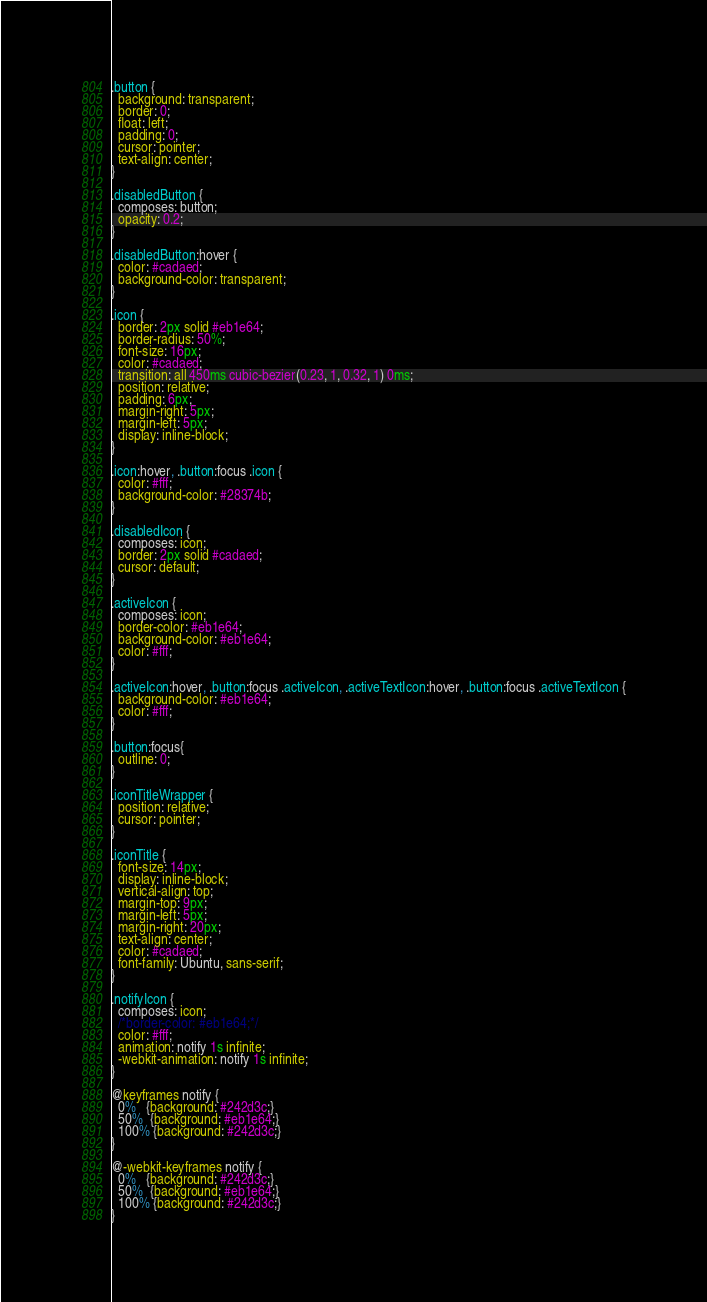Convert code to text. <code><loc_0><loc_0><loc_500><loc_500><_CSS_>.button {
  background: transparent;
  border: 0;
  float: left;
  padding: 0;
  cursor: pointer;
  text-align: center;
}

.disabledButton {
  composes: button;
  opacity: 0.2;
}

.disabledButton:hover {
  color: #cadaed;
  background-color: transparent;
}

.icon {
  border: 2px solid #eb1e64;
  border-radius: 50%;
  font-size: 16px;
  color: #cadaed;
  transition: all 450ms cubic-bezier(0.23, 1, 0.32, 1) 0ms;
  position: relative;
  padding: 6px;
  margin-right: 5px;
  margin-left: 5px;
  display: inline-block;
}

.icon:hover, .button:focus .icon {
  color: #fff;
  background-color: #28374b;
}

.disabledIcon {
  composes: icon;
  border: 2px solid #cadaed;
  cursor: default;
}

.activeIcon {
  composes: icon;
  border-color: #eb1e64;
  background-color: #eb1e64;
  color: #fff;
}

.activeIcon:hover, .button:focus .activeIcon, .activeTextIcon:hover, .button:focus .activeTextIcon {
  background-color: #eb1e64;
  color: #fff;
}

.button:focus{
  outline: 0;
}

.iconTitleWrapper {
  position: relative;
  cursor: pointer;
}

.iconTitle {
  font-size: 14px;
  display: inline-block;
  vertical-align: top;
  margin-top: 9px;
  margin-left: 5px;
  margin-right: 20px;
  text-align: center;
  color: #cadaed;
  font-family: Ubuntu, sans-serif;
}

.notifyIcon {
  composes: icon;
  /*border-color: #eb1e64;*/
  color: #fff;
  animation: notify 1s infinite;
  -webkit-animation: notify 1s infinite;
}

@keyframes notify {
  0%   {background: #242d3c;}
  50%  {background: #eb1e64;}
  100% {background: #242d3c;}
}

@-webkit-keyframes notify {
  0%   {background: #242d3c;}
  50%  {background: #eb1e64;}
  100% {background: #242d3c;}
}
</code> 